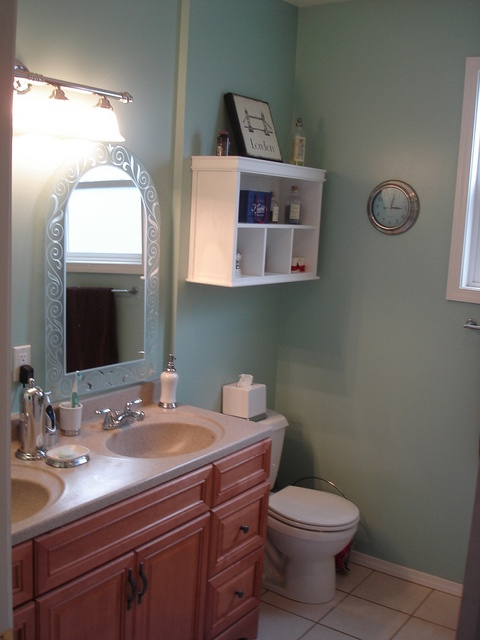Describe the objects in this image and their specific colors. I can see toilet in gray and black tones, sink in gray, tan, and darkgray tones, sink in gray and brown tones, clock in gray and black tones, and bottle in gray and black tones in this image. 